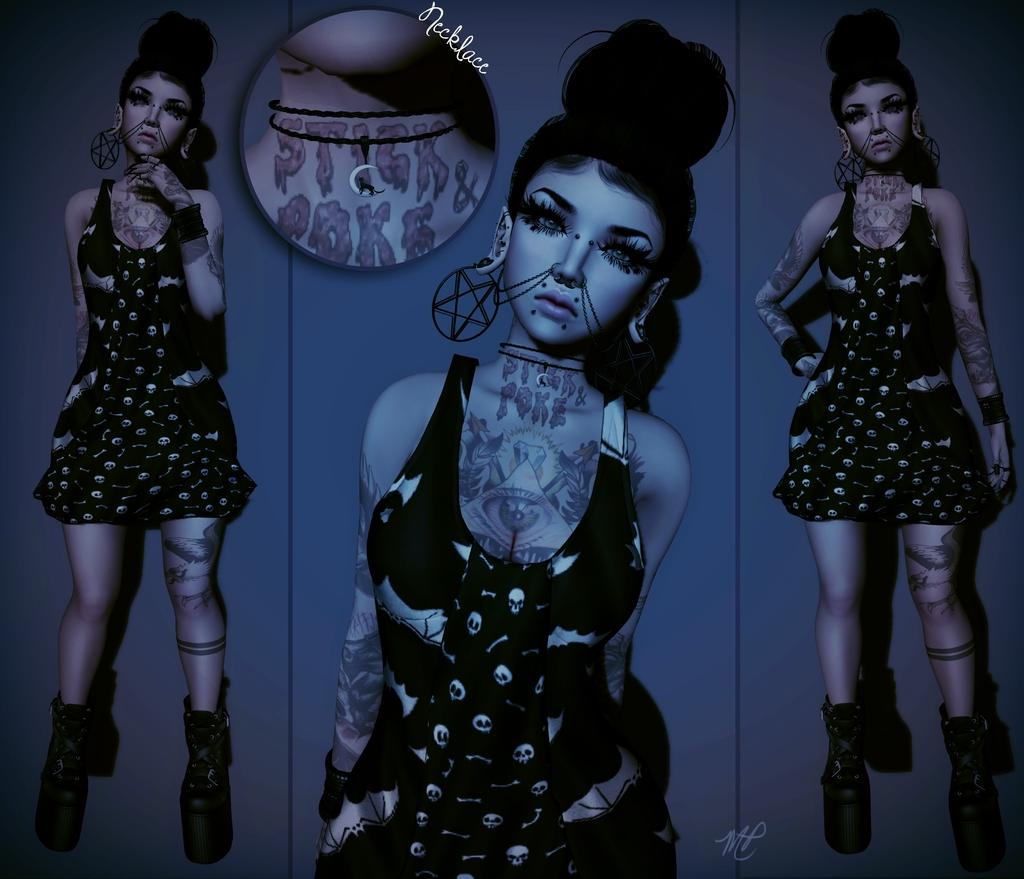How many girls are present in the image? There are three girls in the image. What are the girls doing in the image? The girls are standing beside each other. What is the background element that resembles a mirror? There is a background that resembles a mirror in the image. Where is the mirror located in the image? The mirror is attached to a wall. What type of silk fabric is draped over the mirror in the image? There is no silk fabric present in the image; the mirror is attached to a wall without any additional decorations. 